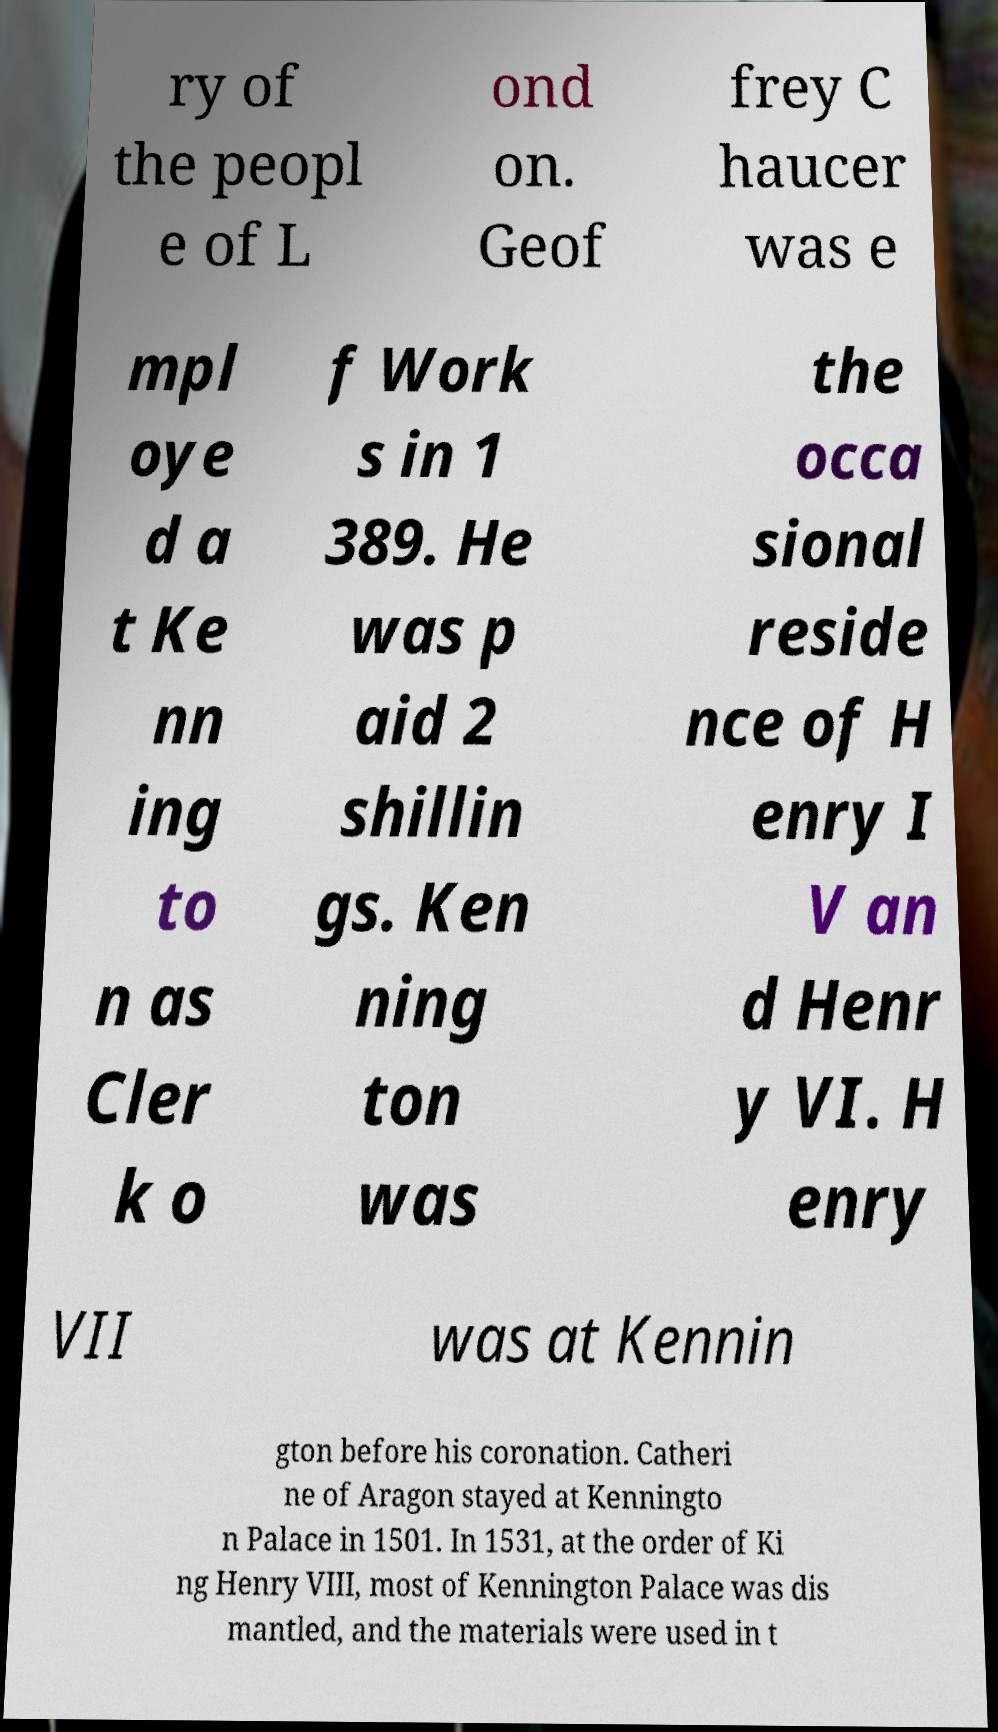Please identify and transcribe the text found in this image. ry of the peopl e of L ond on. Geof frey C haucer was e mpl oye d a t Ke nn ing to n as Cler k o f Work s in 1 389. He was p aid 2 shillin gs. Ken ning ton was the occa sional reside nce of H enry I V an d Henr y VI. H enry VII was at Kennin gton before his coronation. Catheri ne of Aragon stayed at Kenningto n Palace in 1501. In 1531, at the order of Ki ng Henry VIII, most of Kennington Palace was dis mantled, and the materials were used in t 